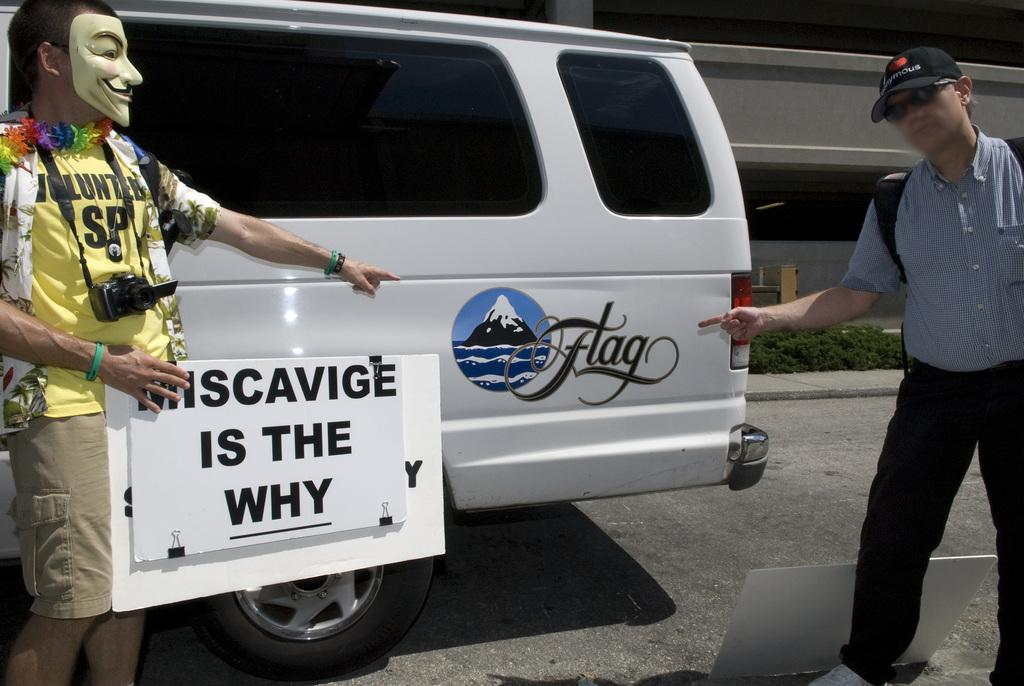<image>
Give a short and clear explanation of the subsequent image. A man pointing at a white van that has the word Flag next to an ocean scene. 